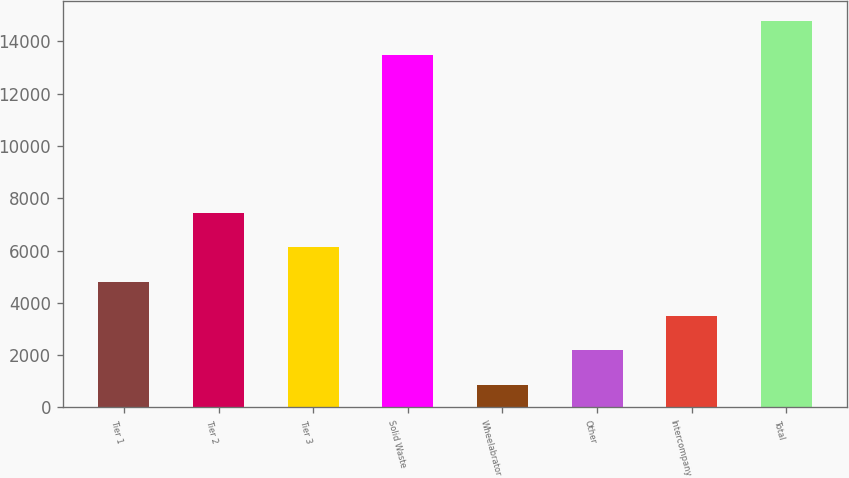Convert chart. <chart><loc_0><loc_0><loc_500><loc_500><bar_chart><fcel>Tier 1<fcel>Tier 2<fcel>Tier 3<fcel>Solid Waste<fcel>Wheelabrator<fcel>Other<fcel>Intercompany<fcel>Total<nl><fcel>4812.6<fcel>7440.2<fcel>6126.4<fcel>13477<fcel>845<fcel>2185<fcel>3498.8<fcel>14790.8<nl></chart> 